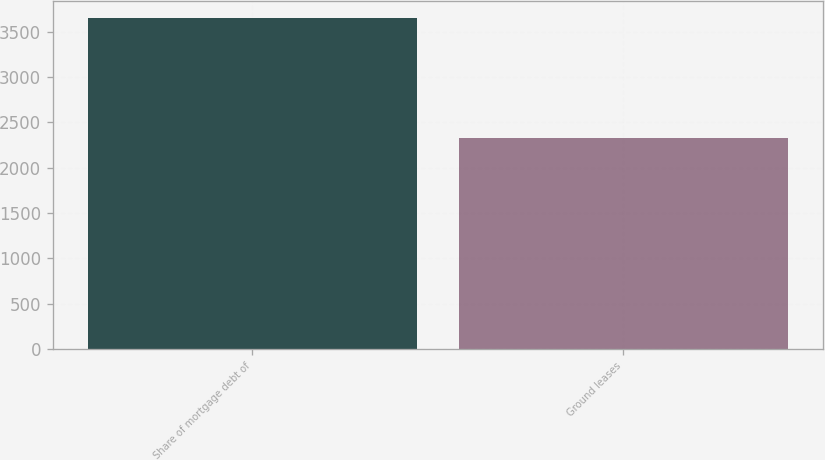<chart> <loc_0><loc_0><loc_500><loc_500><bar_chart><fcel>Share of mortgage debt of<fcel>Ground leases<nl><fcel>3652<fcel>2327<nl></chart> 